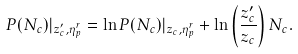Convert formula to latex. <formula><loc_0><loc_0><loc_500><loc_500>P ( N _ { c } ) | _ { z _ { c } ^ { \prime } , \eta _ { p } ^ { r } } = \ln P ( N _ { c } ) | _ { z _ { c } , \eta _ { p } ^ { r } } + \ln \left ( \frac { z _ { c } ^ { \prime } } { z _ { c } } \right ) N _ { c } .</formula> 